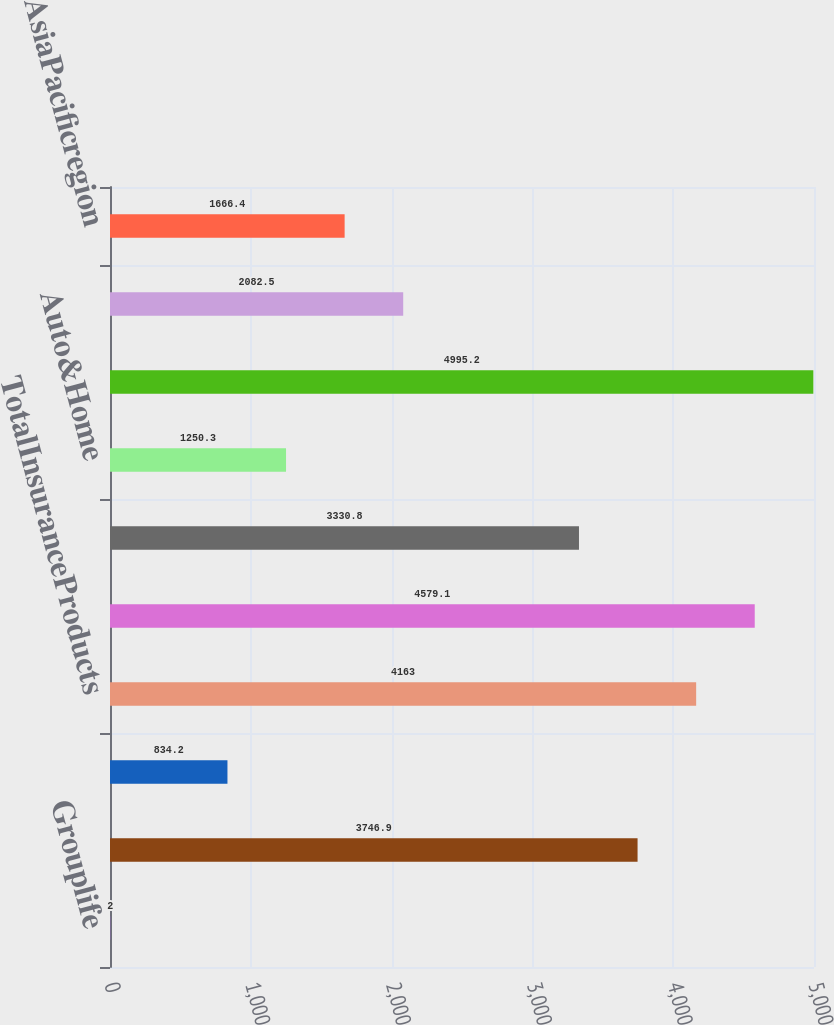Convert chart. <chart><loc_0><loc_0><loc_500><loc_500><bar_chart><fcel>Grouplife<fcel>Individuallife<fcel>Non-medicalhealth<fcel>TotalInsuranceProducts<fcel>RetirementProducts<fcel>CorporateBenefitFunding<fcel>Auto&Home<fcel>TotalUSBusiness<fcel>LatinAmericaregion<fcel>AsiaPacificregion<nl><fcel>2<fcel>3746.9<fcel>834.2<fcel>4163<fcel>4579.1<fcel>3330.8<fcel>1250.3<fcel>4995.2<fcel>2082.5<fcel>1666.4<nl></chart> 